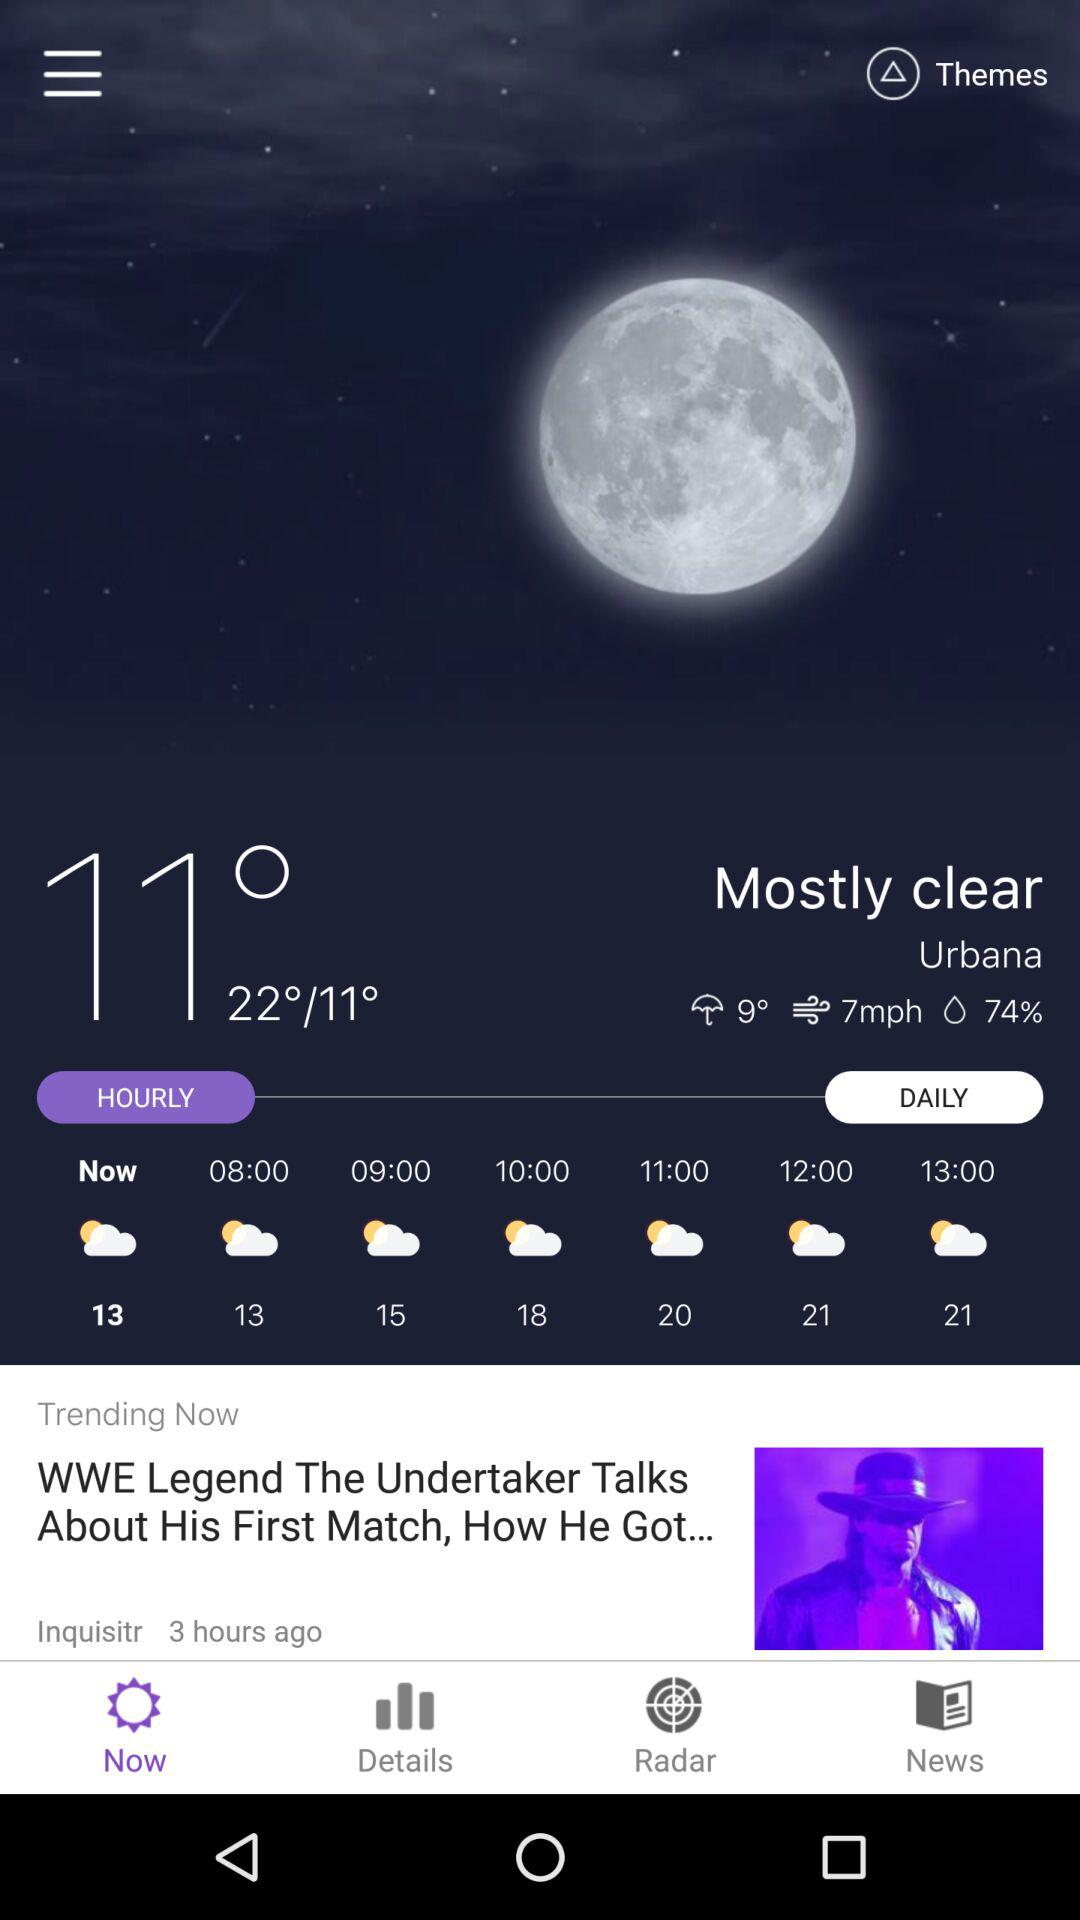How many hours are there between 08:00 and 13:00?
Answer the question using a single word or phrase. 5 